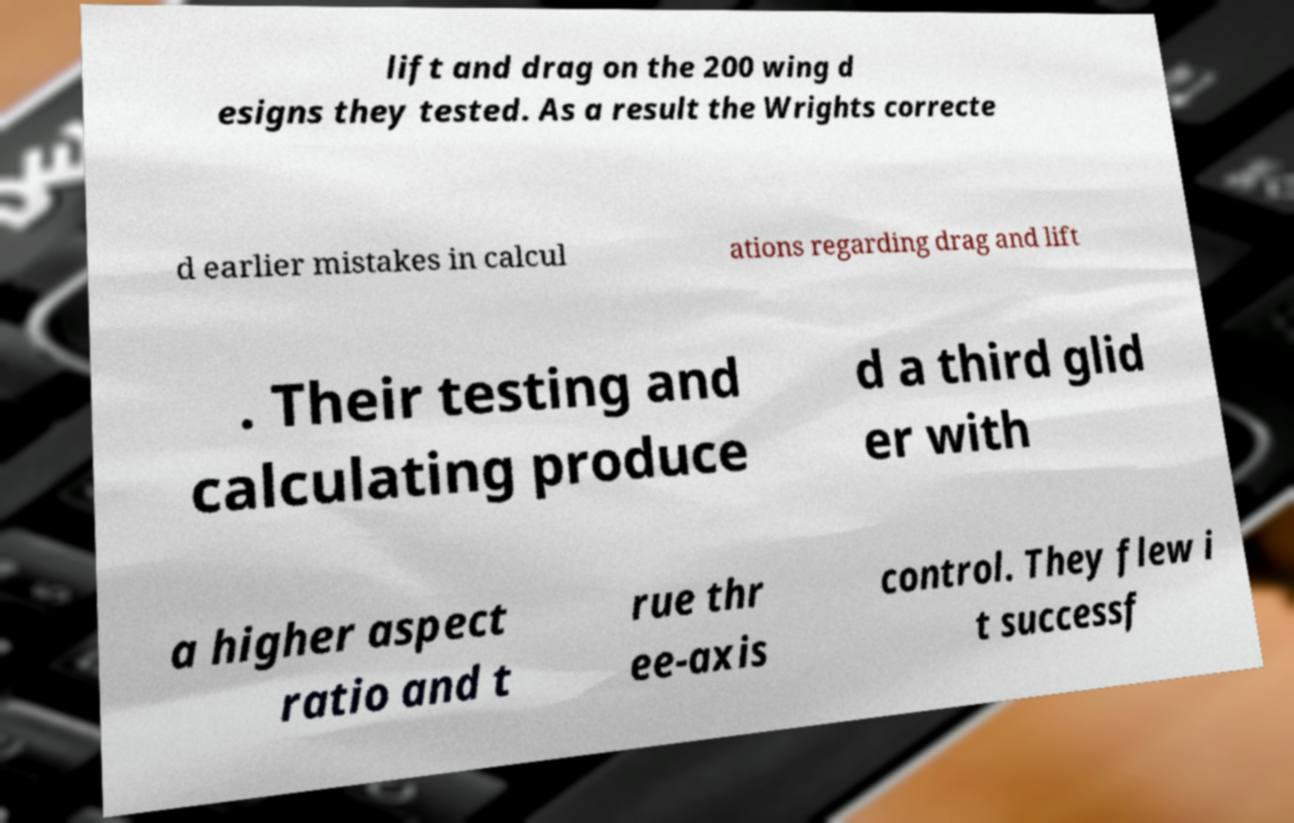Please identify and transcribe the text found in this image. lift and drag on the 200 wing d esigns they tested. As a result the Wrights correcte d earlier mistakes in calcul ations regarding drag and lift . Their testing and calculating produce d a third glid er with a higher aspect ratio and t rue thr ee-axis control. They flew i t successf 